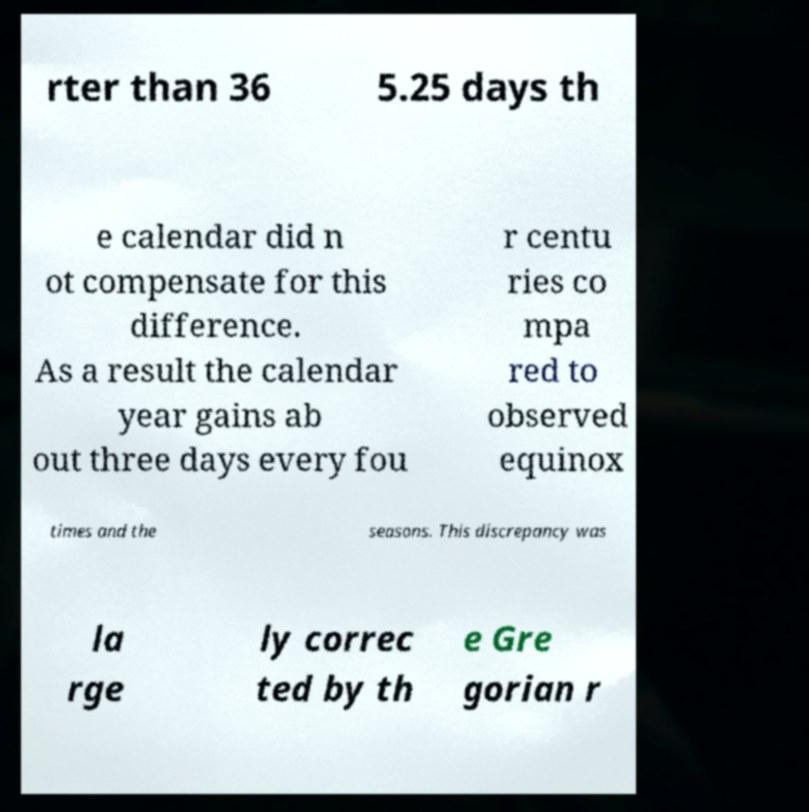Can you accurately transcribe the text from the provided image for me? rter than 36 5.25 days th e calendar did n ot compensate for this difference. As a result the calendar year gains ab out three days every fou r centu ries co mpa red to observed equinox times and the seasons. This discrepancy was la rge ly correc ted by th e Gre gorian r 